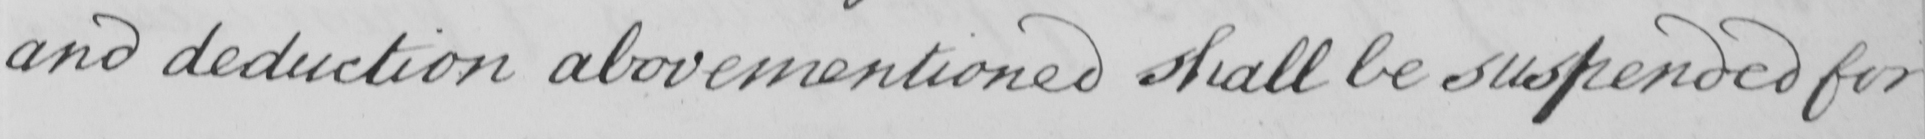Transcribe the text shown in this historical manuscript line. and deduction abovementioned shall be suspended for 